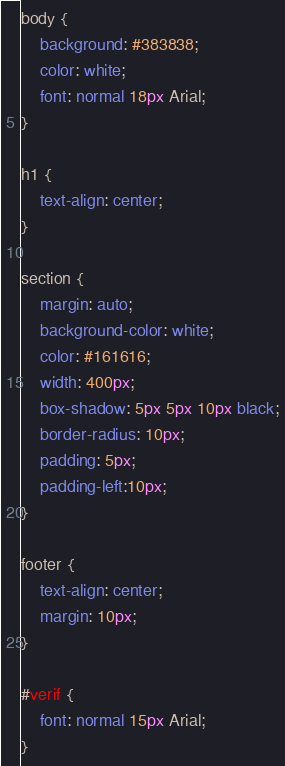<code> <loc_0><loc_0><loc_500><loc_500><_CSS_>body {
    background: #383838;
    color: white;
    font: normal 18px Arial;
}

h1 {
    text-align: center;
}

section {   
    margin: auto;
    background-color: white;
    color: #161616;
    width: 400px;
    box-shadow: 5px 5px 10px black;
    border-radius: 10px;
    padding: 5px;
    padding-left:10px;
}

footer {
    text-align: center;
    margin: 10px;
}

#verif {
    font: normal 15px Arial;
}
</code> 